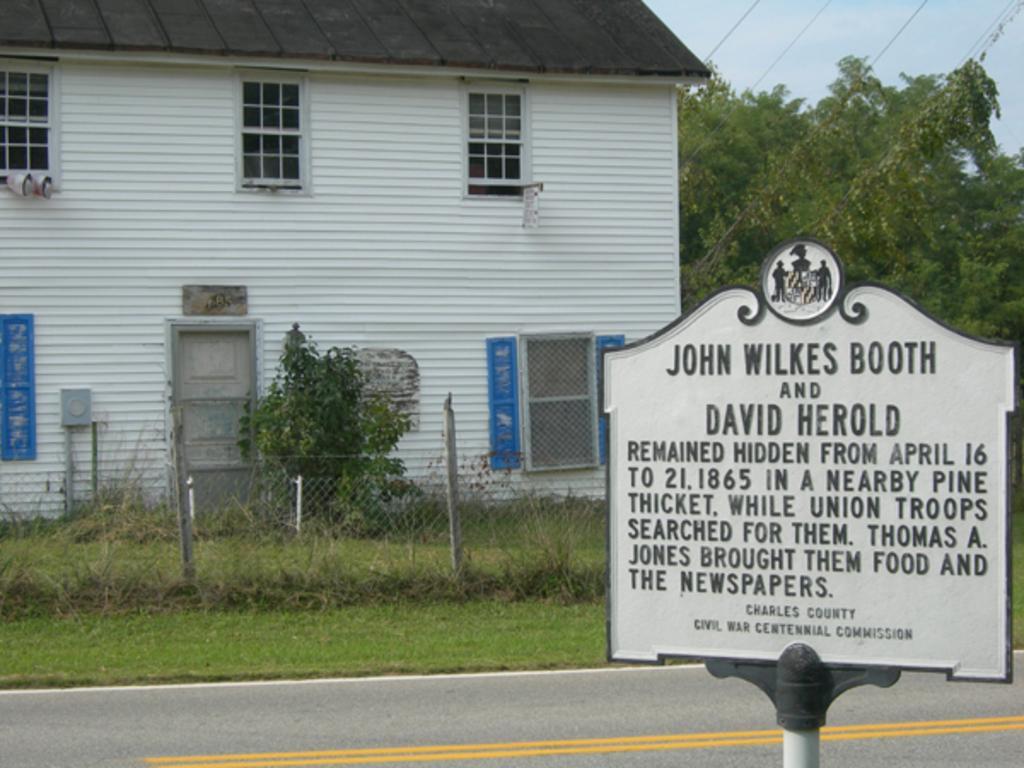Could you give a brief overview of what you see in this image? In the center of the image there is a building. On the right there are trees. At the bottom we can see a board and a fence and there is grass. 